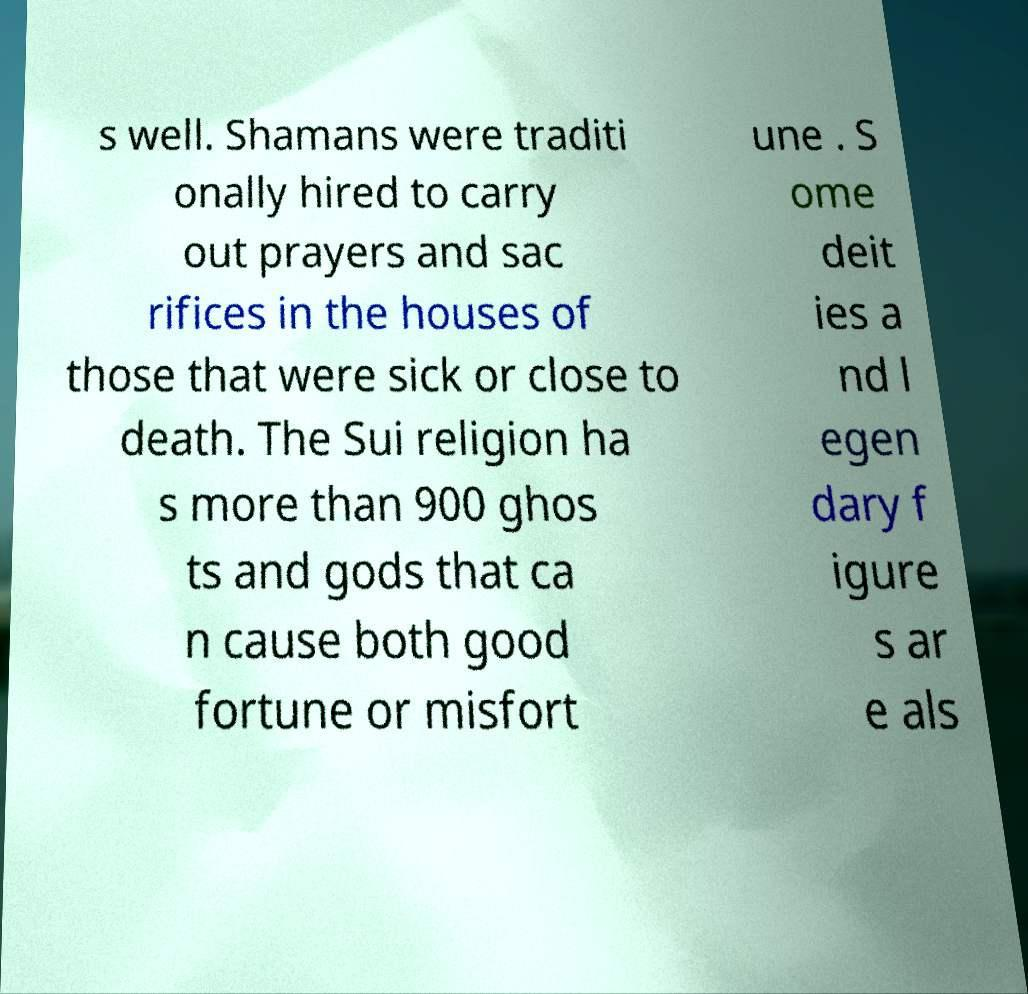I need the written content from this picture converted into text. Can you do that? s well. Shamans were traditi onally hired to carry out prayers and sac rifices in the houses of those that were sick or close to death. The Sui religion ha s more than 900 ghos ts and gods that ca n cause both good fortune or misfort une . S ome deit ies a nd l egen dary f igure s ar e als 